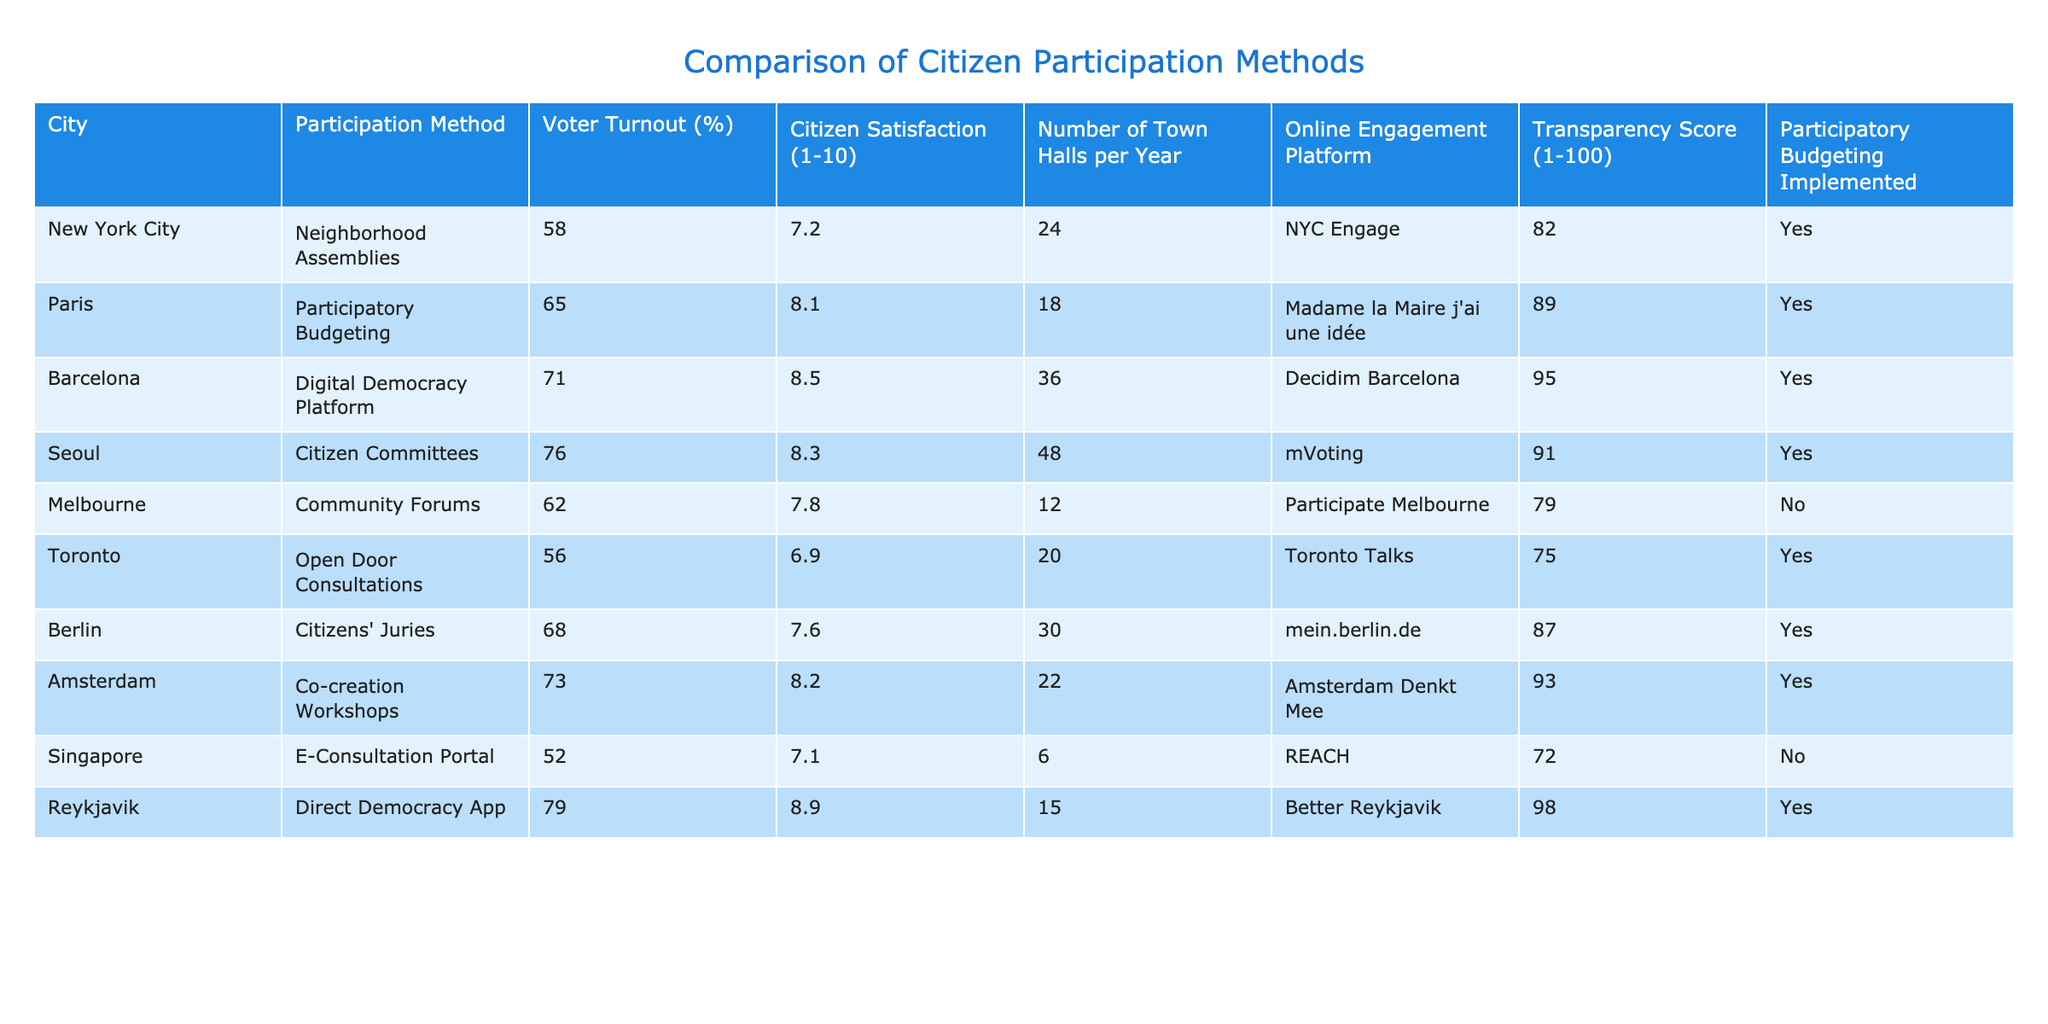What city has the highest voter turnout? By examining the "Voter Turnout (%)" column, I look for the highest percentage. Reykjavik shows a turnout of 79%, which is the maximum value in the table.
Answer: Reykjavik What is the citizen satisfaction score for the participatory budgeting method in Paris? I refer to the row for Paris and look under the "Citizen Satisfaction (1-10)" column to find that the score is 8.1.
Answer: 8.1 Which cities have implemented participatory budgeting? I check the "Participatory Budgeting Implemented" column and identify the cities with "Yes". The cities are Paris, Barcelona, Seoul, Berlin, Amsterdam, and Reykjavik.
Answer: Paris, Barcelona, Seoul, Berlin, Amsterdam, Reykjavik What is the average transparency score of cities that have implemented participatory budgeting? First, I list the transparency scores for cities that implemented participatory budgeting: Paris (89), Barcelona (95), Seoul (91), Berlin (87), Amsterdam (93), and Reykjavik (98). Then, I calculate the average: (89 + 95 + 91 + 87 + 93 + 98) / 6 = 93.83.
Answer: 93.83 Which city has the lowest voter turnout and what is the score? I scan the table for the lowest value in the "Voter Turnout (%)" column. Singapore has the lowest voter turnout with 52%.
Answer: Singapore, 52% Is citizen satisfaction in Toronto higher than in Melbourne? I compare the "Citizen Satisfaction (1-10)" scores for both cities. Toronto has 6.9 and Melbourne has 7.8. Since 7.8 is greater than 6.9, the satisfaction in Melbourne is indeed higher than in Toronto.
Answer: No Which city has the most town halls per year, and how many are there? I examine the "Number of Town Halls per Year" column to find the city with the highest number. Seoul has 48 town halls, which is the most.
Answer: Seoul, 48 How does the online engagement platform "Decidim Barcelona" rank in terms of transparency score? I look for Barcelona's entry in the table and find the corresponding transparency score. It is 95 out of 100, which is high compared to other cities.
Answer: 95 What is the difference in voter turnout between Barcelona and Singapore? I find the voter turnout values: Barcelona is 71% and Singapore is 52%. The difference is calculated as 71 - 52 = 19.
Answer: 19 